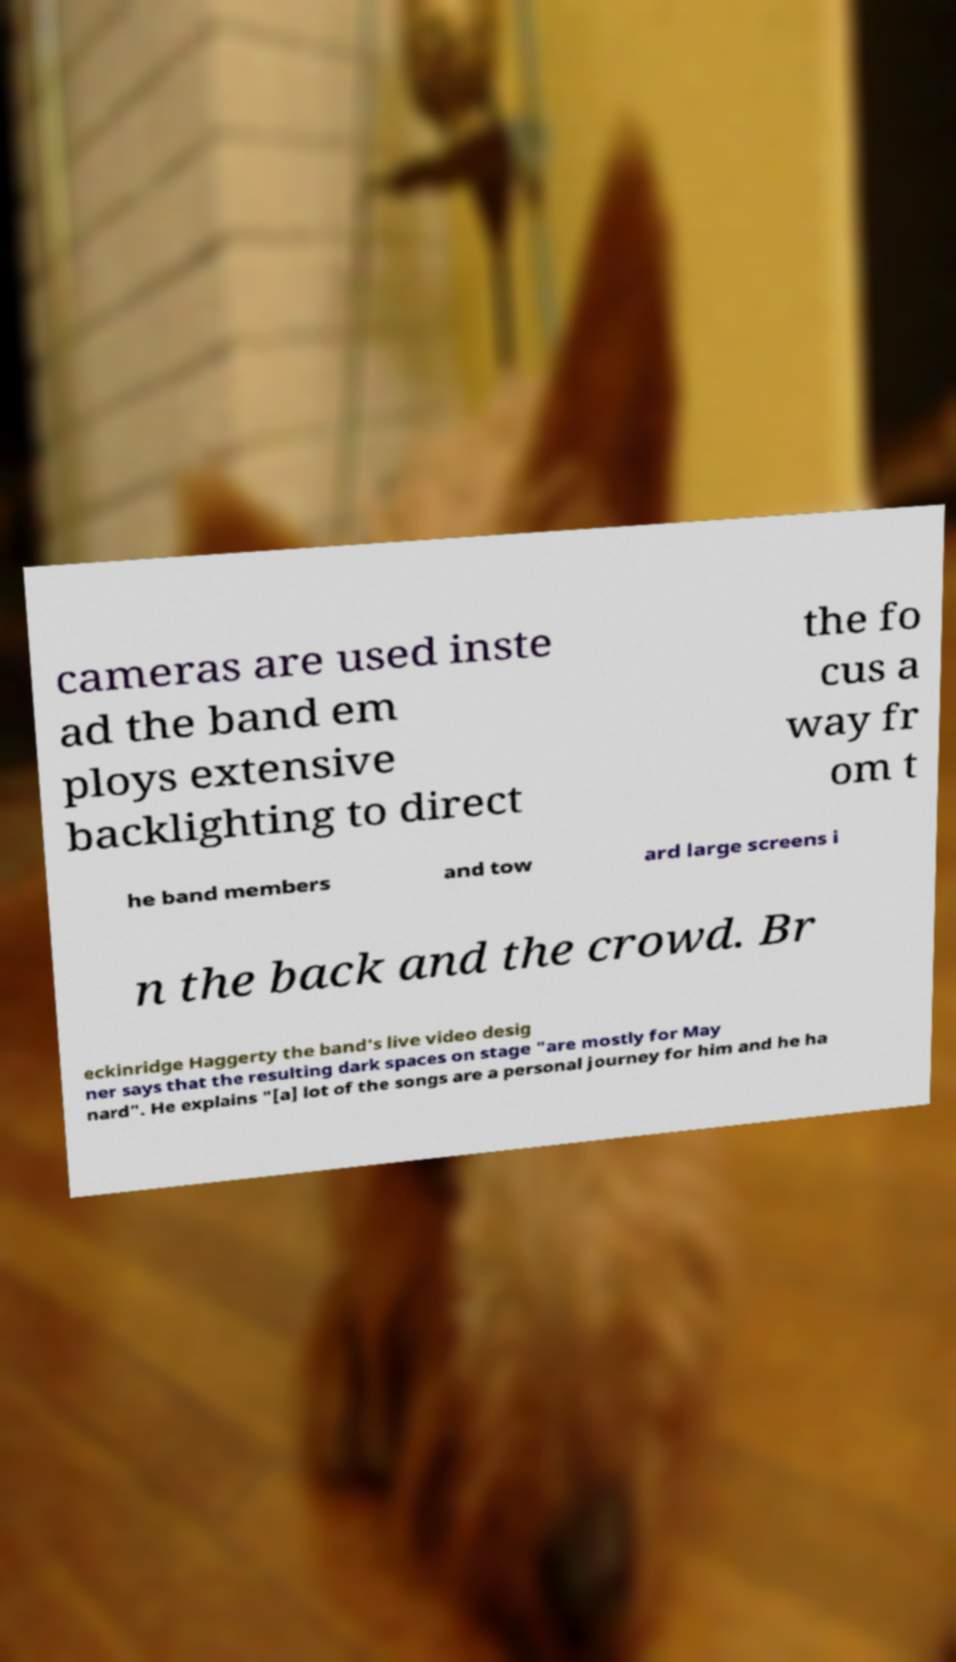I need the written content from this picture converted into text. Can you do that? cameras are used inste ad the band em ploys extensive backlighting to direct the fo cus a way fr om t he band members and tow ard large screens i n the back and the crowd. Br eckinridge Haggerty the band's live video desig ner says that the resulting dark spaces on stage "are mostly for May nard". He explains "[a] lot of the songs are a personal journey for him and he ha 